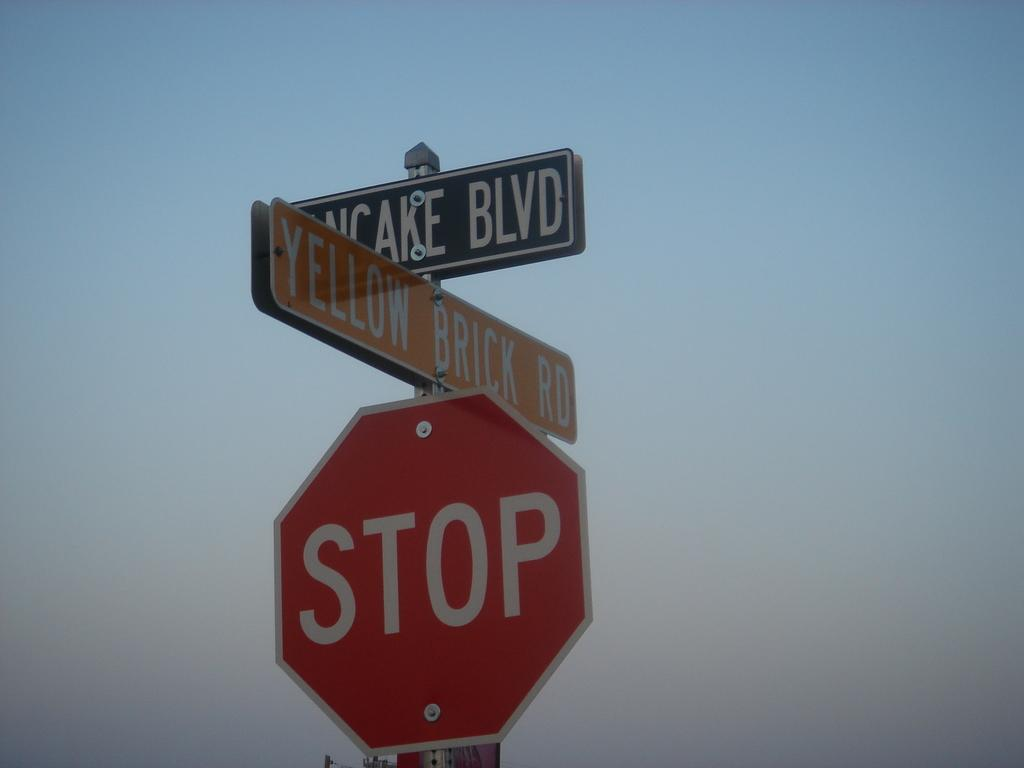<image>
Render a clear and concise summary of the photo. A red stop sign has street signs above it 